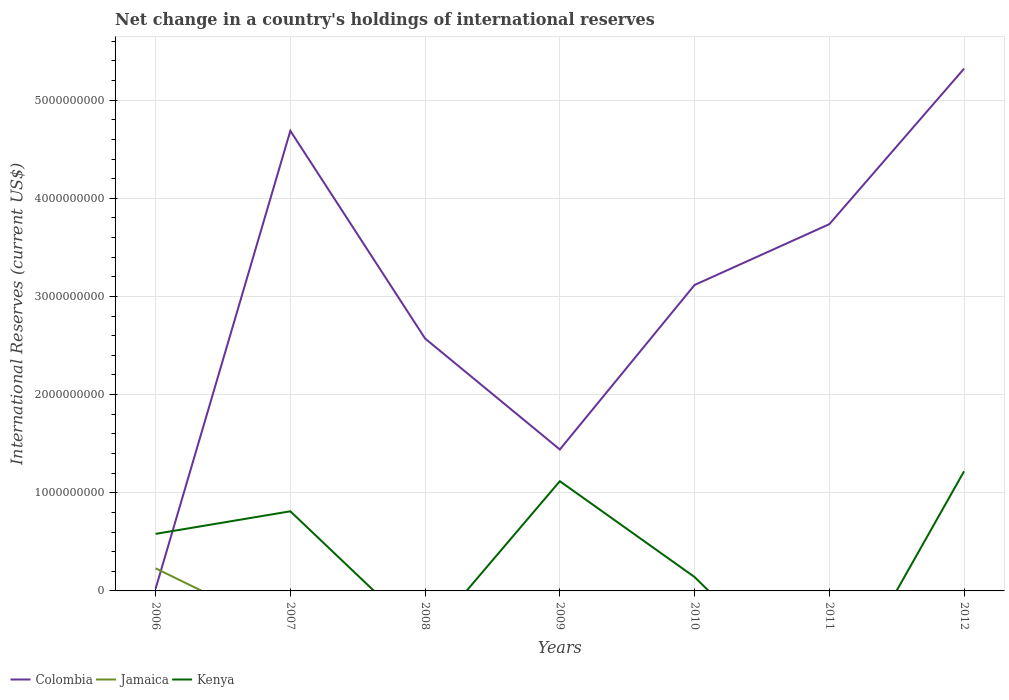Does the line corresponding to Kenya intersect with the line corresponding to Colombia?
Your answer should be compact. Yes. Is the number of lines equal to the number of legend labels?
Provide a short and direct response. No. What is the total international reserves in Colombia in the graph?
Ensure brevity in your answer.  -3.88e+09. What is the difference between the highest and the second highest international reserves in Kenya?
Give a very brief answer. 1.22e+09. How many lines are there?
Your answer should be compact. 3. How many years are there in the graph?
Ensure brevity in your answer.  7. What is the difference between two consecutive major ticks on the Y-axis?
Offer a very short reply. 1.00e+09. Are the values on the major ticks of Y-axis written in scientific E-notation?
Offer a terse response. No. Does the graph contain grids?
Ensure brevity in your answer.  Yes. Where does the legend appear in the graph?
Keep it short and to the point. Bottom left. How are the legend labels stacked?
Offer a terse response. Horizontal. What is the title of the graph?
Provide a short and direct response. Net change in a country's holdings of international reserves. Does "Rwanda" appear as one of the legend labels in the graph?
Ensure brevity in your answer.  No. What is the label or title of the Y-axis?
Offer a very short reply. International Reserves (current US$). What is the International Reserves (current US$) of Colombia in 2006?
Make the answer very short. 2.26e+07. What is the International Reserves (current US$) in Jamaica in 2006?
Give a very brief answer. 2.30e+08. What is the International Reserves (current US$) of Kenya in 2006?
Give a very brief answer. 5.81e+08. What is the International Reserves (current US$) in Colombia in 2007?
Provide a short and direct response. 4.69e+09. What is the International Reserves (current US$) in Kenya in 2007?
Your answer should be compact. 8.11e+08. What is the International Reserves (current US$) of Colombia in 2008?
Your answer should be very brief. 2.57e+09. What is the International Reserves (current US$) in Kenya in 2008?
Provide a succinct answer. 0. What is the International Reserves (current US$) of Colombia in 2009?
Offer a very short reply. 1.44e+09. What is the International Reserves (current US$) of Kenya in 2009?
Your response must be concise. 1.12e+09. What is the International Reserves (current US$) in Colombia in 2010?
Make the answer very short. 3.12e+09. What is the International Reserves (current US$) in Kenya in 2010?
Provide a short and direct response. 1.42e+08. What is the International Reserves (current US$) in Colombia in 2011?
Offer a terse response. 3.74e+09. What is the International Reserves (current US$) of Jamaica in 2011?
Provide a short and direct response. 0. What is the International Reserves (current US$) of Colombia in 2012?
Provide a succinct answer. 5.32e+09. What is the International Reserves (current US$) in Jamaica in 2012?
Give a very brief answer. 0. What is the International Reserves (current US$) in Kenya in 2012?
Your answer should be very brief. 1.22e+09. Across all years, what is the maximum International Reserves (current US$) of Colombia?
Keep it short and to the point. 5.32e+09. Across all years, what is the maximum International Reserves (current US$) in Jamaica?
Provide a short and direct response. 2.30e+08. Across all years, what is the maximum International Reserves (current US$) in Kenya?
Ensure brevity in your answer.  1.22e+09. Across all years, what is the minimum International Reserves (current US$) of Colombia?
Offer a very short reply. 2.26e+07. Across all years, what is the minimum International Reserves (current US$) in Jamaica?
Provide a short and direct response. 0. What is the total International Reserves (current US$) in Colombia in the graph?
Ensure brevity in your answer.  2.09e+1. What is the total International Reserves (current US$) in Jamaica in the graph?
Offer a terse response. 2.30e+08. What is the total International Reserves (current US$) of Kenya in the graph?
Your response must be concise. 3.87e+09. What is the difference between the International Reserves (current US$) in Colombia in 2006 and that in 2007?
Offer a terse response. -4.67e+09. What is the difference between the International Reserves (current US$) in Kenya in 2006 and that in 2007?
Offer a very short reply. -2.30e+08. What is the difference between the International Reserves (current US$) in Colombia in 2006 and that in 2008?
Offer a terse response. -2.55e+09. What is the difference between the International Reserves (current US$) of Colombia in 2006 and that in 2009?
Your response must be concise. -1.42e+09. What is the difference between the International Reserves (current US$) of Kenya in 2006 and that in 2009?
Make the answer very short. -5.37e+08. What is the difference between the International Reserves (current US$) in Colombia in 2006 and that in 2010?
Keep it short and to the point. -3.09e+09. What is the difference between the International Reserves (current US$) in Kenya in 2006 and that in 2010?
Keep it short and to the point. 4.40e+08. What is the difference between the International Reserves (current US$) in Colombia in 2006 and that in 2011?
Offer a very short reply. -3.71e+09. What is the difference between the International Reserves (current US$) of Colombia in 2006 and that in 2012?
Your response must be concise. -5.30e+09. What is the difference between the International Reserves (current US$) of Kenya in 2006 and that in 2012?
Give a very brief answer. -6.38e+08. What is the difference between the International Reserves (current US$) of Colombia in 2007 and that in 2008?
Offer a very short reply. 2.12e+09. What is the difference between the International Reserves (current US$) of Colombia in 2007 and that in 2009?
Your answer should be compact. 3.25e+09. What is the difference between the International Reserves (current US$) in Kenya in 2007 and that in 2009?
Your response must be concise. -3.07e+08. What is the difference between the International Reserves (current US$) in Colombia in 2007 and that in 2010?
Your answer should be very brief. 1.57e+09. What is the difference between the International Reserves (current US$) in Kenya in 2007 and that in 2010?
Give a very brief answer. 6.70e+08. What is the difference between the International Reserves (current US$) in Colombia in 2007 and that in 2011?
Make the answer very short. 9.51e+08. What is the difference between the International Reserves (current US$) of Colombia in 2007 and that in 2012?
Provide a succinct answer. -6.34e+08. What is the difference between the International Reserves (current US$) in Kenya in 2007 and that in 2012?
Provide a short and direct response. -4.08e+08. What is the difference between the International Reserves (current US$) in Colombia in 2008 and that in 2009?
Your answer should be compact. 1.13e+09. What is the difference between the International Reserves (current US$) in Colombia in 2008 and that in 2010?
Make the answer very short. -5.46e+08. What is the difference between the International Reserves (current US$) in Colombia in 2008 and that in 2011?
Give a very brief answer. -1.17e+09. What is the difference between the International Reserves (current US$) of Colombia in 2008 and that in 2012?
Your response must be concise. -2.75e+09. What is the difference between the International Reserves (current US$) of Colombia in 2009 and that in 2010?
Your answer should be compact. -1.68e+09. What is the difference between the International Reserves (current US$) in Kenya in 2009 and that in 2010?
Your response must be concise. 9.76e+08. What is the difference between the International Reserves (current US$) of Colombia in 2009 and that in 2011?
Your answer should be compact. -2.30e+09. What is the difference between the International Reserves (current US$) of Colombia in 2009 and that in 2012?
Your response must be concise. -3.88e+09. What is the difference between the International Reserves (current US$) of Kenya in 2009 and that in 2012?
Offer a very short reply. -1.01e+08. What is the difference between the International Reserves (current US$) of Colombia in 2010 and that in 2011?
Keep it short and to the point. -6.19e+08. What is the difference between the International Reserves (current US$) of Colombia in 2010 and that in 2012?
Your answer should be compact. -2.20e+09. What is the difference between the International Reserves (current US$) in Kenya in 2010 and that in 2012?
Give a very brief answer. -1.08e+09. What is the difference between the International Reserves (current US$) of Colombia in 2011 and that in 2012?
Your answer should be very brief. -1.58e+09. What is the difference between the International Reserves (current US$) of Colombia in 2006 and the International Reserves (current US$) of Kenya in 2007?
Your answer should be very brief. -7.89e+08. What is the difference between the International Reserves (current US$) of Jamaica in 2006 and the International Reserves (current US$) of Kenya in 2007?
Ensure brevity in your answer.  -5.81e+08. What is the difference between the International Reserves (current US$) of Colombia in 2006 and the International Reserves (current US$) of Kenya in 2009?
Your answer should be very brief. -1.10e+09. What is the difference between the International Reserves (current US$) in Jamaica in 2006 and the International Reserves (current US$) in Kenya in 2009?
Give a very brief answer. -8.88e+08. What is the difference between the International Reserves (current US$) in Colombia in 2006 and the International Reserves (current US$) in Kenya in 2010?
Provide a succinct answer. -1.19e+08. What is the difference between the International Reserves (current US$) of Jamaica in 2006 and the International Reserves (current US$) of Kenya in 2010?
Your answer should be very brief. 8.87e+07. What is the difference between the International Reserves (current US$) of Colombia in 2006 and the International Reserves (current US$) of Kenya in 2012?
Keep it short and to the point. -1.20e+09. What is the difference between the International Reserves (current US$) in Jamaica in 2006 and the International Reserves (current US$) in Kenya in 2012?
Give a very brief answer. -9.89e+08. What is the difference between the International Reserves (current US$) of Colombia in 2007 and the International Reserves (current US$) of Kenya in 2009?
Your answer should be compact. 3.57e+09. What is the difference between the International Reserves (current US$) of Colombia in 2007 and the International Reserves (current US$) of Kenya in 2010?
Offer a terse response. 4.55e+09. What is the difference between the International Reserves (current US$) of Colombia in 2007 and the International Reserves (current US$) of Kenya in 2012?
Your answer should be compact. 3.47e+09. What is the difference between the International Reserves (current US$) of Colombia in 2008 and the International Reserves (current US$) of Kenya in 2009?
Offer a very short reply. 1.45e+09. What is the difference between the International Reserves (current US$) in Colombia in 2008 and the International Reserves (current US$) in Kenya in 2010?
Your answer should be very brief. 2.43e+09. What is the difference between the International Reserves (current US$) in Colombia in 2008 and the International Reserves (current US$) in Kenya in 2012?
Give a very brief answer. 1.35e+09. What is the difference between the International Reserves (current US$) of Colombia in 2009 and the International Reserves (current US$) of Kenya in 2010?
Make the answer very short. 1.30e+09. What is the difference between the International Reserves (current US$) of Colombia in 2009 and the International Reserves (current US$) of Kenya in 2012?
Offer a terse response. 2.22e+08. What is the difference between the International Reserves (current US$) of Colombia in 2010 and the International Reserves (current US$) of Kenya in 2012?
Ensure brevity in your answer.  1.90e+09. What is the difference between the International Reserves (current US$) in Colombia in 2011 and the International Reserves (current US$) in Kenya in 2012?
Offer a very short reply. 2.52e+09. What is the average International Reserves (current US$) in Colombia per year?
Give a very brief answer. 2.99e+09. What is the average International Reserves (current US$) in Jamaica per year?
Give a very brief answer. 3.29e+07. What is the average International Reserves (current US$) of Kenya per year?
Offer a terse response. 5.53e+08. In the year 2006, what is the difference between the International Reserves (current US$) in Colombia and International Reserves (current US$) in Jamaica?
Make the answer very short. -2.08e+08. In the year 2006, what is the difference between the International Reserves (current US$) in Colombia and International Reserves (current US$) in Kenya?
Provide a succinct answer. -5.59e+08. In the year 2006, what is the difference between the International Reserves (current US$) of Jamaica and International Reserves (current US$) of Kenya?
Your answer should be very brief. -3.51e+08. In the year 2007, what is the difference between the International Reserves (current US$) of Colombia and International Reserves (current US$) of Kenya?
Give a very brief answer. 3.88e+09. In the year 2009, what is the difference between the International Reserves (current US$) in Colombia and International Reserves (current US$) in Kenya?
Your answer should be compact. 3.23e+08. In the year 2010, what is the difference between the International Reserves (current US$) of Colombia and International Reserves (current US$) of Kenya?
Provide a short and direct response. 2.98e+09. In the year 2012, what is the difference between the International Reserves (current US$) of Colombia and International Reserves (current US$) of Kenya?
Make the answer very short. 4.10e+09. What is the ratio of the International Reserves (current US$) of Colombia in 2006 to that in 2007?
Your response must be concise. 0. What is the ratio of the International Reserves (current US$) in Kenya in 2006 to that in 2007?
Provide a succinct answer. 0.72. What is the ratio of the International Reserves (current US$) of Colombia in 2006 to that in 2008?
Keep it short and to the point. 0.01. What is the ratio of the International Reserves (current US$) in Colombia in 2006 to that in 2009?
Your answer should be compact. 0.02. What is the ratio of the International Reserves (current US$) in Kenya in 2006 to that in 2009?
Give a very brief answer. 0.52. What is the ratio of the International Reserves (current US$) in Colombia in 2006 to that in 2010?
Keep it short and to the point. 0.01. What is the ratio of the International Reserves (current US$) of Kenya in 2006 to that in 2010?
Provide a short and direct response. 4.11. What is the ratio of the International Reserves (current US$) in Colombia in 2006 to that in 2011?
Give a very brief answer. 0.01. What is the ratio of the International Reserves (current US$) of Colombia in 2006 to that in 2012?
Keep it short and to the point. 0. What is the ratio of the International Reserves (current US$) in Kenya in 2006 to that in 2012?
Offer a terse response. 0.48. What is the ratio of the International Reserves (current US$) of Colombia in 2007 to that in 2008?
Offer a terse response. 1.82. What is the ratio of the International Reserves (current US$) of Colombia in 2007 to that in 2009?
Make the answer very short. 3.25. What is the ratio of the International Reserves (current US$) in Kenya in 2007 to that in 2009?
Your response must be concise. 0.73. What is the ratio of the International Reserves (current US$) of Colombia in 2007 to that in 2010?
Offer a terse response. 1.5. What is the ratio of the International Reserves (current US$) of Kenya in 2007 to that in 2010?
Keep it short and to the point. 5.73. What is the ratio of the International Reserves (current US$) of Colombia in 2007 to that in 2011?
Your response must be concise. 1.25. What is the ratio of the International Reserves (current US$) of Colombia in 2007 to that in 2012?
Ensure brevity in your answer.  0.88. What is the ratio of the International Reserves (current US$) in Kenya in 2007 to that in 2012?
Provide a succinct answer. 0.67. What is the ratio of the International Reserves (current US$) in Colombia in 2008 to that in 2009?
Ensure brevity in your answer.  1.78. What is the ratio of the International Reserves (current US$) of Colombia in 2008 to that in 2010?
Provide a succinct answer. 0.82. What is the ratio of the International Reserves (current US$) in Colombia in 2008 to that in 2011?
Offer a very short reply. 0.69. What is the ratio of the International Reserves (current US$) in Colombia in 2008 to that in 2012?
Your answer should be very brief. 0.48. What is the ratio of the International Reserves (current US$) of Colombia in 2009 to that in 2010?
Give a very brief answer. 0.46. What is the ratio of the International Reserves (current US$) in Kenya in 2009 to that in 2010?
Ensure brevity in your answer.  7.9. What is the ratio of the International Reserves (current US$) of Colombia in 2009 to that in 2011?
Your answer should be very brief. 0.39. What is the ratio of the International Reserves (current US$) of Colombia in 2009 to that in 2012?
Your answer should be compact. 0.27. What is the ratio of the International Reserves (current US$) of Kenya in 2009 to that in 2012?
Keep it short and to the point. 0.92. What is the ratio of the International Reserves (current US$) of Colombia in 2010 to that in 2011?
Offer a very short reply. 0.83. What is the ratio of the International Reserves (current US$) in Colombia in 2010 to that in 2012?
Offer a very short reply. 0.59. What is the ratio of the International Reserves (current US$) of Kenya in 2010 to that in 2012?
Give a very brief answer. 0.12. What is the ratio of the International Reserves (current US$) in Colombia in 2011 to that in 2012?
Make the answer very short. 0.7. What is the difference between the highest and the second highest International Reserves (current US$) of Colombia?
Keep it short and to the point. 6.34e+08. What is the difference between the highest and the second highest International Reserves (current US$) in Kenya?
Offer a very short reply. 1.01e+08. What is the difference between the highest and the lowest International Reserves (current US$) of Colombia?
Provide a short and direct response. 5.30e+09. What is the difference between the highest and the lowest International Reserves (current US$) of Jamaica?
Keep it short and to the point. 2.30e+08. What is the difference between the highest and the lowest International Reserves (current US$) of Kenya?
Give a very brief answer. 1.22e+09. 